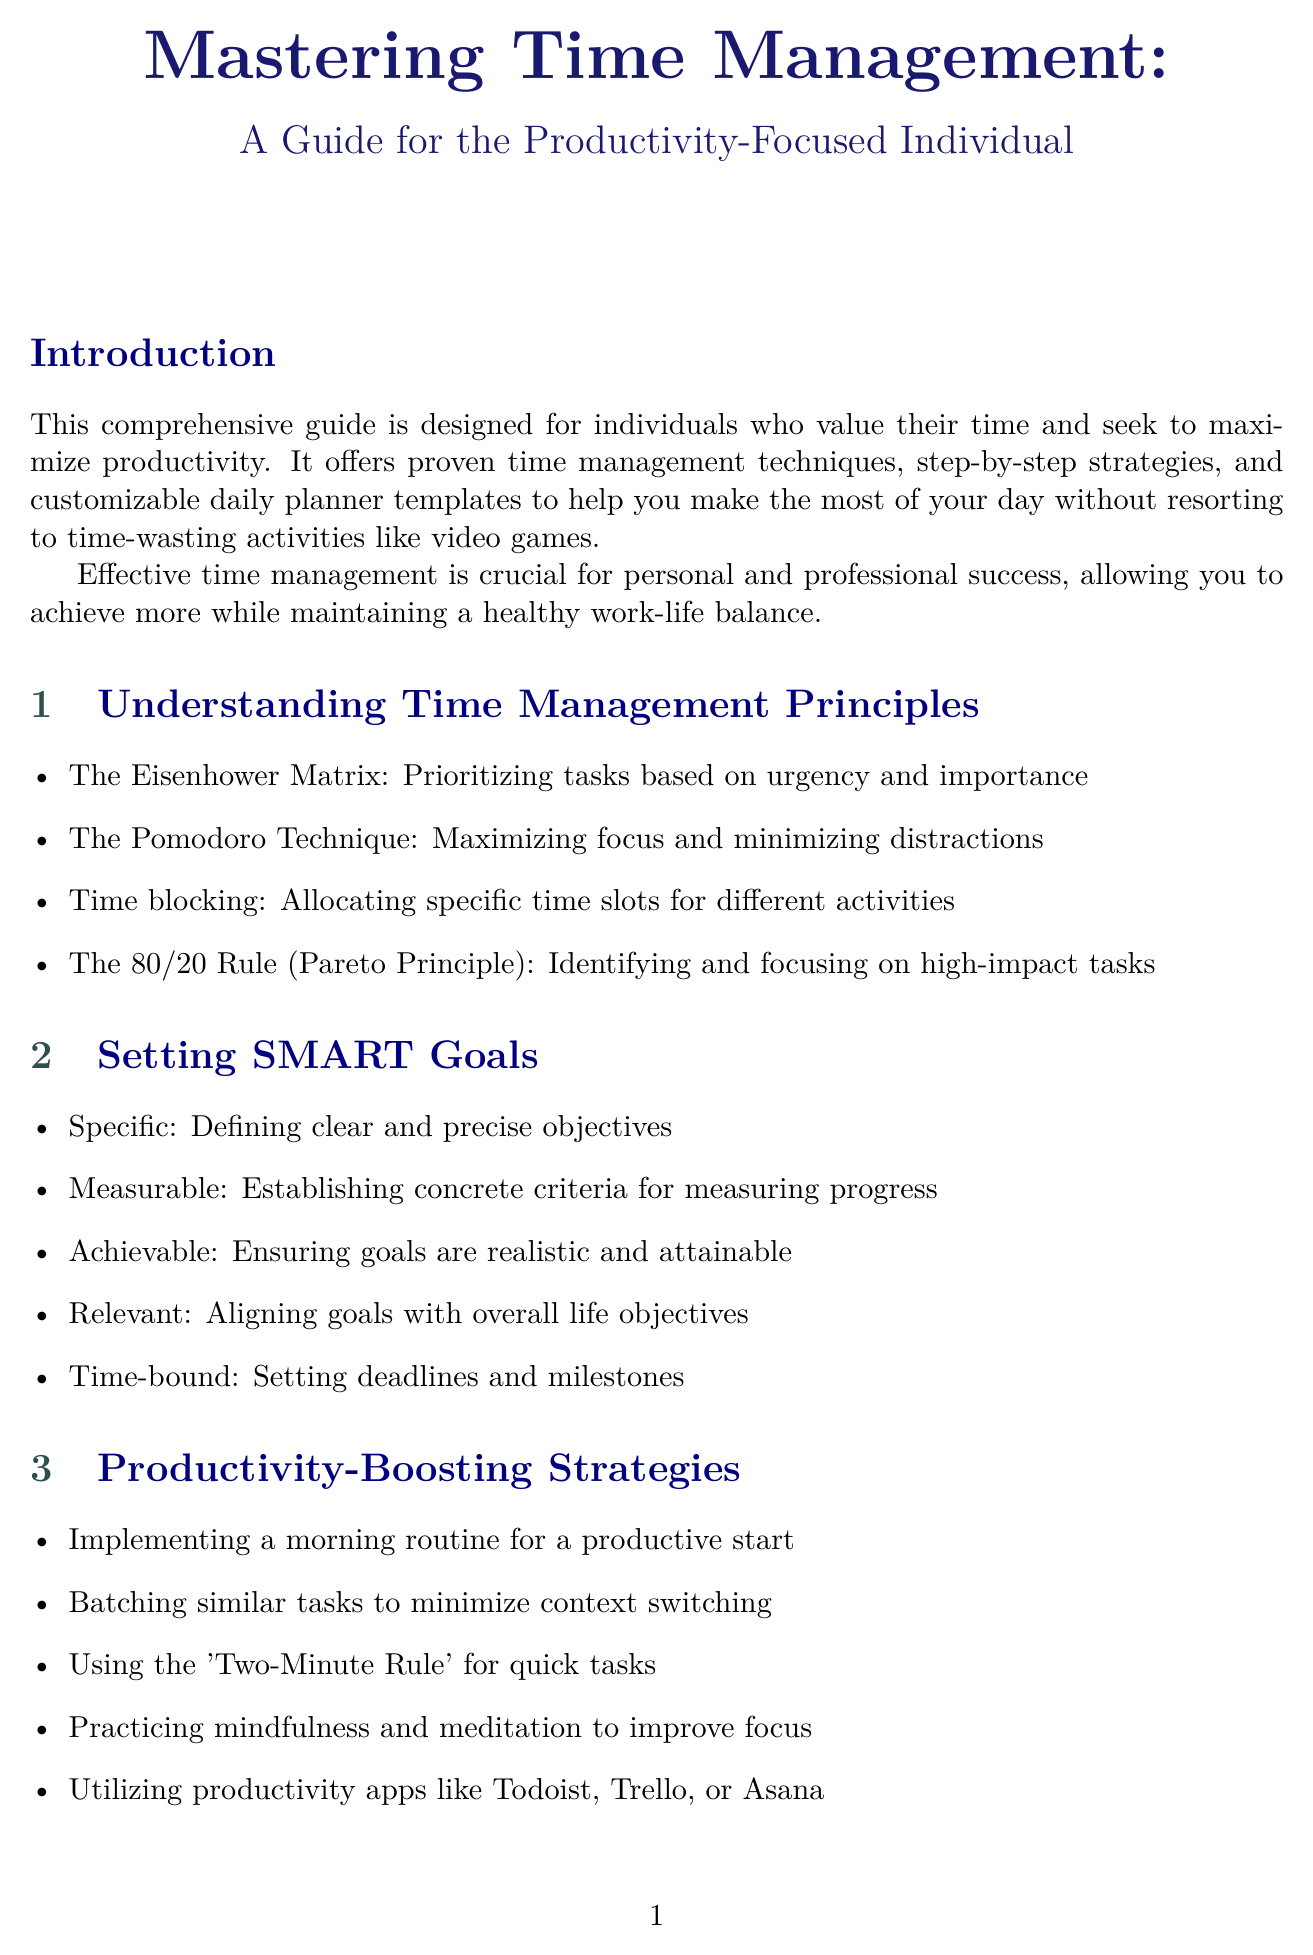What is the title of the guide? The title of the guide is stated prominently at the beginning, which is "Mastering Time Management: A Guide for the Productivity-Focused Individual."
Answer: Mastering Time Management: A Guide for the Productivity-Focused Individual What technique is used for prioritizing tasks? The specific technique for prioritizing tasks based on urgency and importance is mentioned in the principles section of the document.
Answer: The Eisenhower Matrix How many types of daily planner templates are provided? The document lists three different daily planner templates, which can be counted in the relevant section.
Answer: Three What is the main goal of effective time management according to the introduction? The importance of effective time management as stated in the introduction relates to personal and professional success, which can be inferred as allowing achievement while maintaining balance.
Answer: Achieve more while maintaining a healthy work-life balance What rule is associated with focusing on high-impact tasks? The document refers to a specific rule that identifies high-impact tasks and prioritizes them, which can be found in the principles section.
Answer: The 80/20 Rule What is the first section in the chapter on productivity-boosting strategies? The sections are listed in order, and the first will be the first item mentioned under productivity-boosting strategies.
Answer: Implementing a morning routine for a productive start In what case study does a former video game enthusiast reclaim time? The document outlines case studies, one of which specifically mentions a former video game enthusiast's journey in time management.
Answer: From Time-Waster to Time Master Which app is recommended for automatic time-tracking? The resources section lists productivity apps, including one that specializes in automatic time-tracking and analysis.
Answer: RescueTime What is one alternative to video games for relaxation mentioned in the document? Under the section discussing overcoming procrastination and time-wasters, the document suggests alternatives for relaxation and entertainment.
Answer: Alternatives to video games 